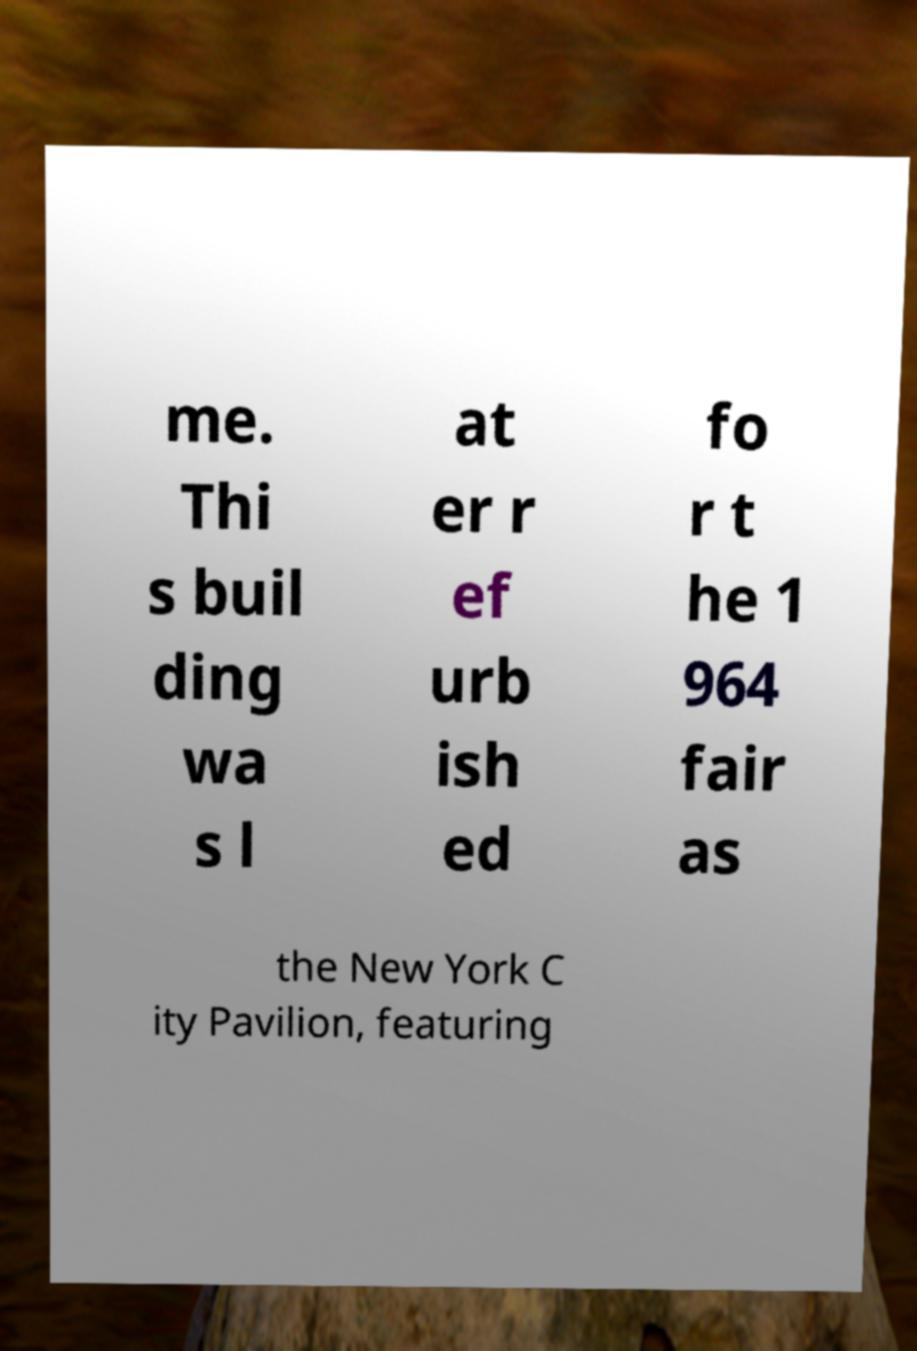For documentation purposes, I need the text within this image transcribed. Could you provide that? me. Thi s buil ding wa s l at er r ef urb ish ed fo r t he 1 964 fair as the New York C ity Pavilion, featuring 